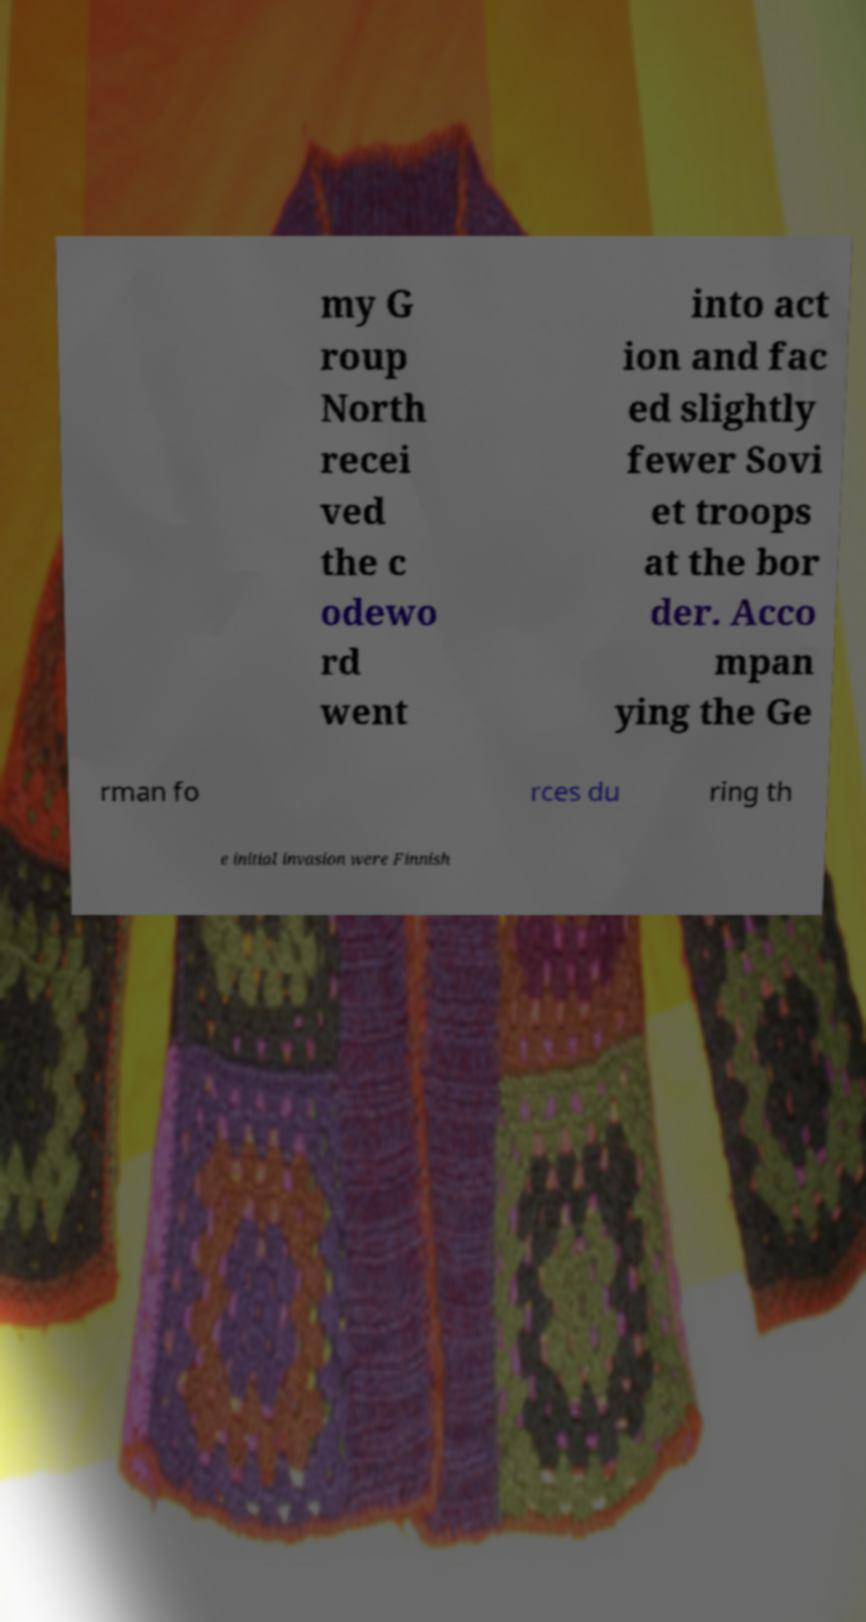Can you read and provide the text displayed in the image?This photo seems to have some interesting text. Can you extract and type it out for me? my G roup North recei ved the c odewo rd went into act ion and fac ed slightly fewer Sovi et troops at the bor der. Acco mpan ying the Ge rman fo rces du ring th e initial invasion were Finnish 